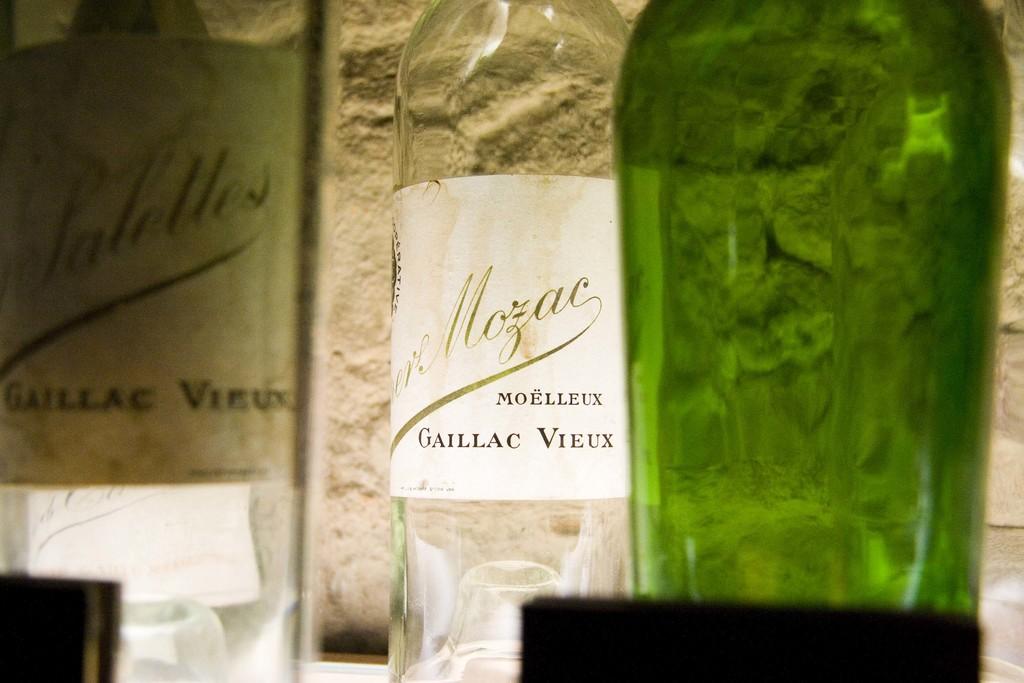What is the name on the bottle?
Provide a succinct answer. Gaillac vieux. 